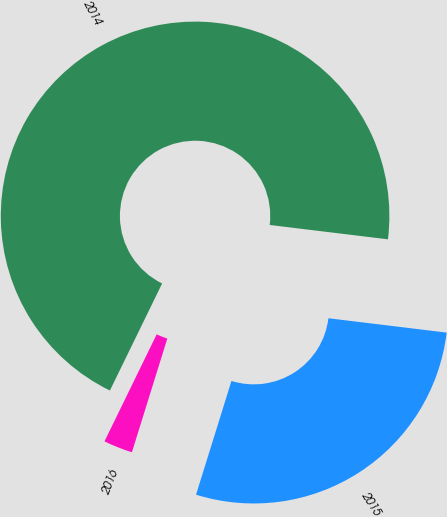<chart> <loc_0><loc_0><loc_500><loc_500><pie_chart><fcel>2016<fcel>2015<fcel>2014<nl><fcel>2.42%<fcel>27.88%<fcel>69.7%<nl></chart> 